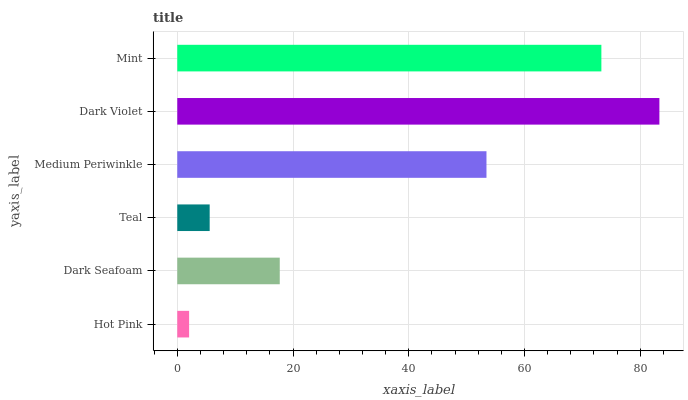Is Hot Pink the minimum?
Answer yes or no. Yes. Is Dark Violet the maximum?
Answer yes or no. Yes. Is Dark Seafoam the minimum?
Answer yes or no. No. Is Dark Seafoam the maximum?
Answer yes or no. No. Is Dark Seafoam greater than Hot Pink?
Answer yes or no. Yes. Is Hot Pink less than Dark Seafoam?
Answer yes or no. Yes. Is Hot Pink greater than Dark Seafoam?
Answer yes or no. No. Is Dark Seafoam less than Hot Pink?
Answer yes or no. No. Is Medium Periwinkle the high median?
Answer yes or no. Yes. Is Dark Seafoam the low median?
Answer yes or no. Yes. Is Dark Violet the high median?
Answer yes or no. No. Is Dark Violet the low median?
Answer yes or no. No. 